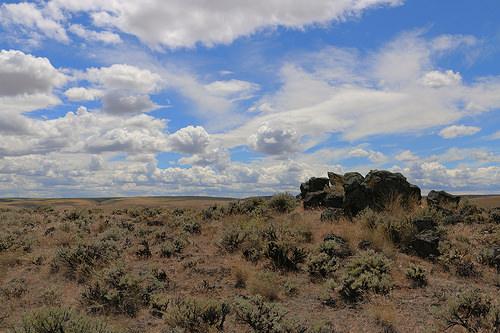<image>
Is the rock on the cloud? No. The rock is not positioned on the cloud. They may be near each other, but the rock is not supported by or resting on top of the cloud. 